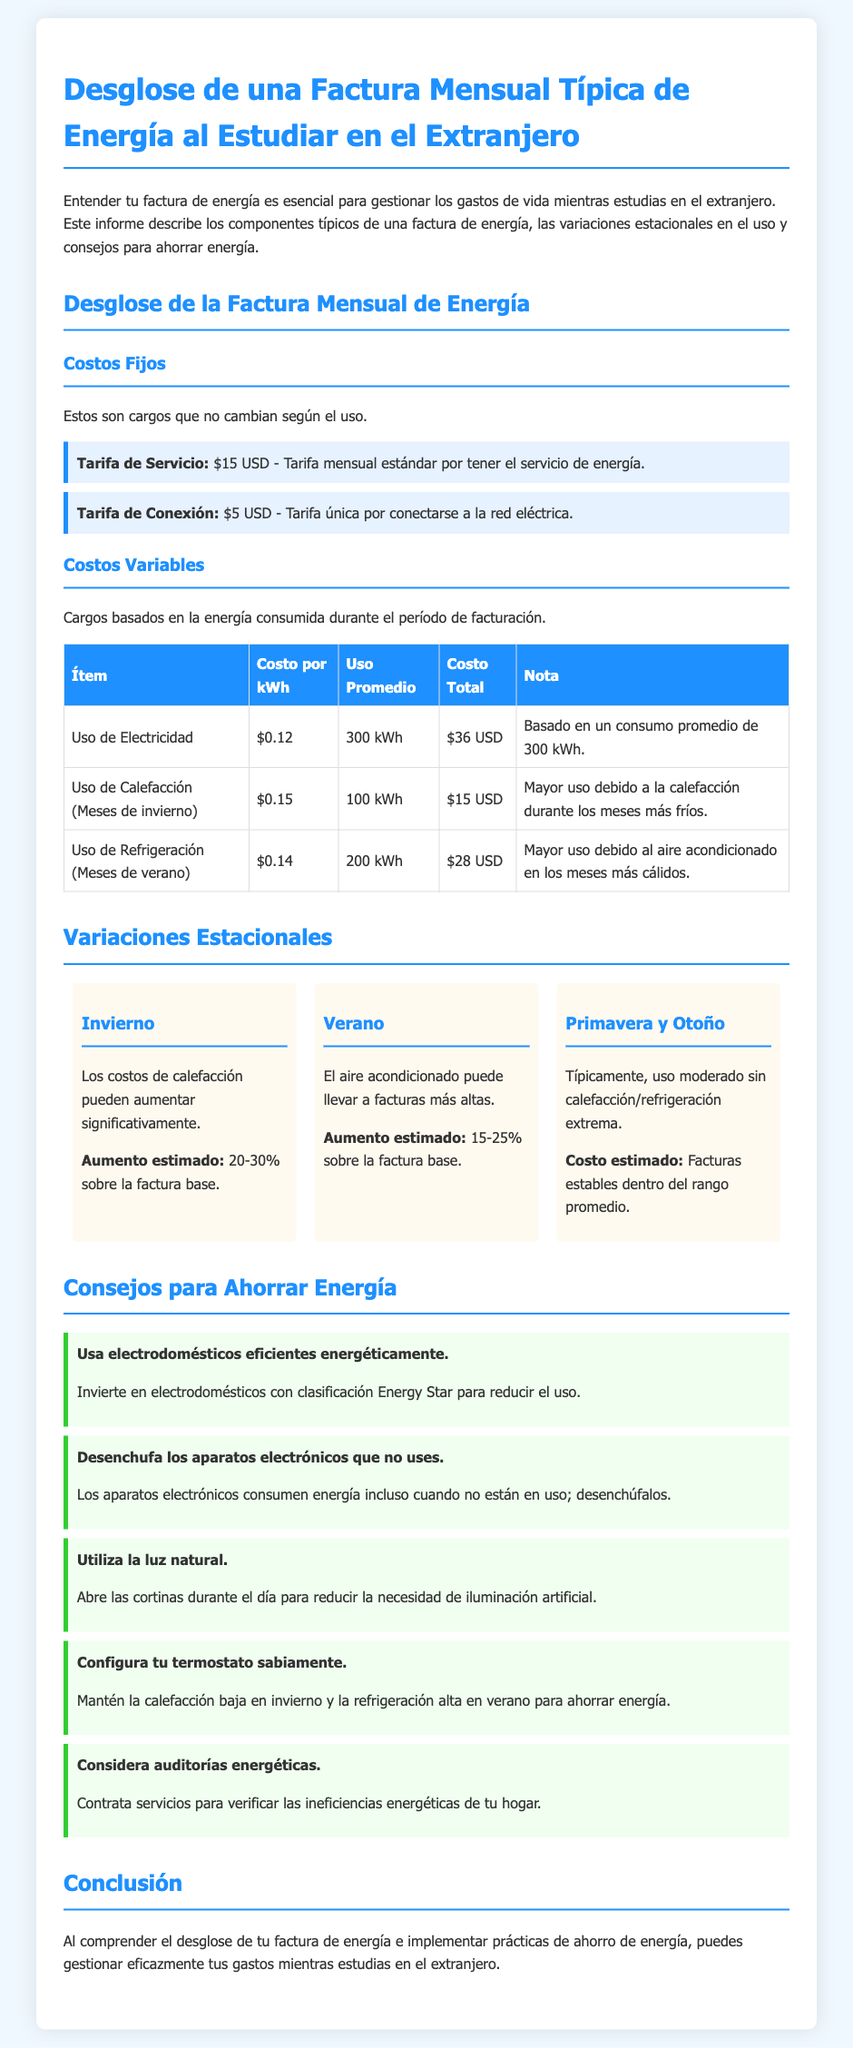¿Cuál es el costo de la tarifa de servicio mensual? La tarifa de servicio mensual es un costo fijo que se indica en la factura.
Answer: $15 USD ¿Cuál es el costo total del uso de electricidad basado en 300 kWh? El uso de electricidad se desglosa en la tabla y muestra su costo total con base en el consumo promedio.
Answer: $36 USD ¿Qué porcentaje puede aumentar la factura en invierno? La sección sobre variaciones estacionales describe un aumento estimado en la factura durante el invierno.
Answer: 20-30% ¿Cuánto cuesta la tarifa de conexión? La tarifa de conexión es un cargo fijo que se detalla en la sección de costos fijos.
Answer: $5 USD ¿Cuál es un consejo para ahorrar energía relacionado con electrodomésticos? Los consejos para ahorrar energía incluyen prácticas para reducir el consumo energético, uno señala sobre los electrodomésticos.
Answer: Usa electrodomésticos eficientes energéticamente ¿Qué temporada tiene un incremento de costos debido al aire acondicionado? La sección que describe variaciones estacionales menciona el uso de aire acondicionado.
Answer: Verano ¿Qué porcentaje puede aumentar la factura en verano? En la sección de variaciones estacionales, se menciona el aumento estimado en la factura debido al aire acondicionado.
Answer: 15-25% 